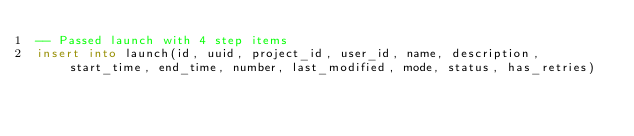Convert code to text. <code><loc_0><loc_0><loc_500><loc_500><_SQL_>-- Passed launch with 4 step items
insert into launch(id, uuid, project_id, user_id, name, description, start_time, end_time, number, last_modified, mode, status, has_retries)</code> 